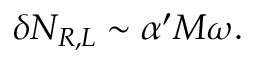<formula> <loc_0><loc_0><loc_500><loc_500>\delta N _ { R , L } \sim \alpha ^ { \prime } M \omega .</formula> 